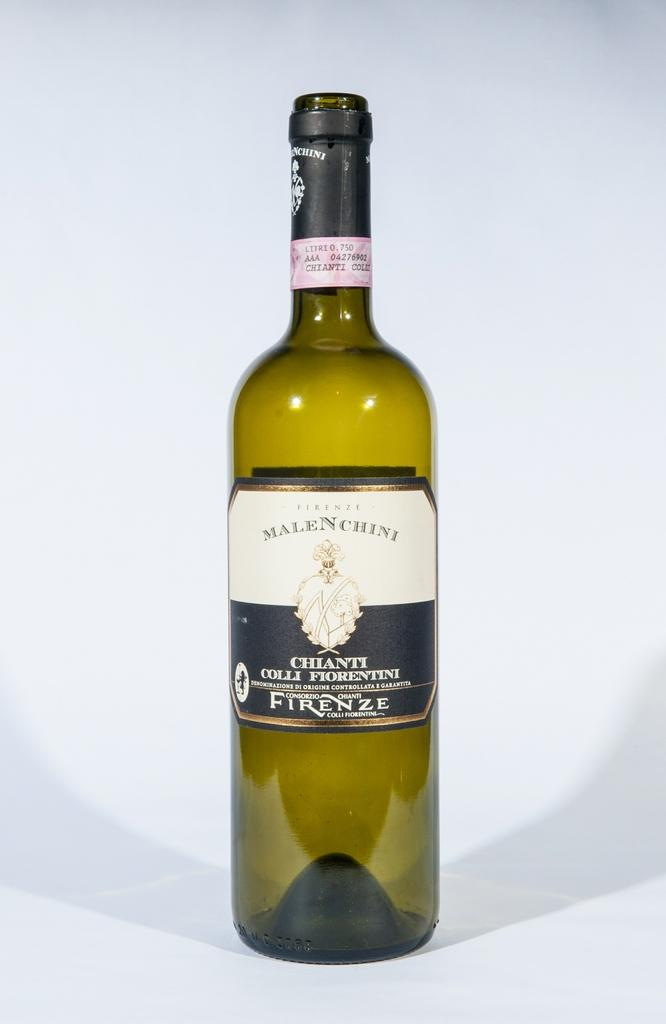<image>
Offer a succinct explanation of the picture presented. a wine bottle with the word Firenze on it 